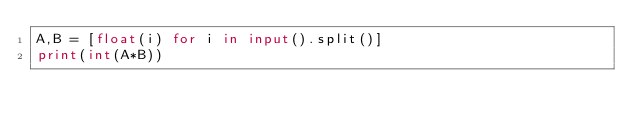Convert code to text. <code><loc_0><loc_0><loc_500><loc_500><_Python_>A,B = [float(i) for i in input().split()]
print(int(A*B))</code> 